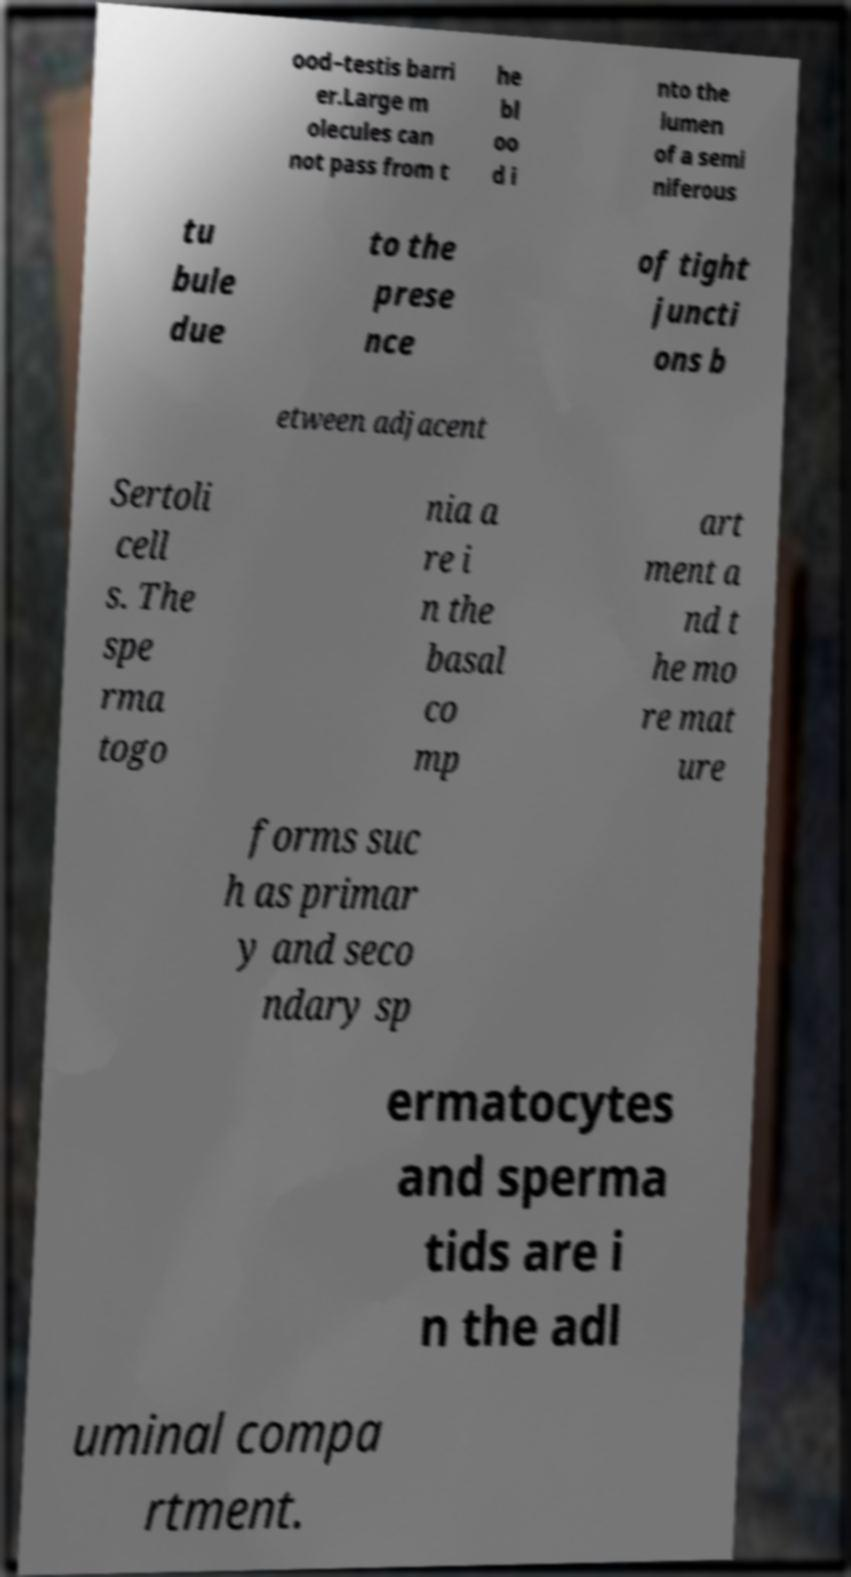Could you assist in decoding the text presented in this image and type it out clearly? ood–testis barri er.Large m olecules can not pass from t he bl oo d i nto the lumen of a semi niferous tu bule due to the prese nce of tight juncti ons b etween adjacent Sertoli cell s. The spe rma togo nia a re i n the basal co mp art ment a nd t he mo re mat ure forms suc h as primar y and seco ndary sp ermatocytes and sperma tids are i n the adl uminal compa rtment. 